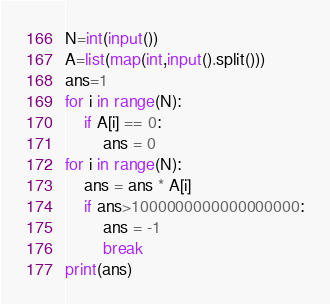<code> <loc_0><loc_0><loc_500><loc_500><_Python_>N=int(input())
A=list(map(int,input().split()))
ans=1
for i in range(N):
    if A[i] == 0:
        ans = 0
for i in range(N):
    ans = ans * A[i]
    if ans>1000000000000000000:
        ans = -1
        break
print(ans)</code> 